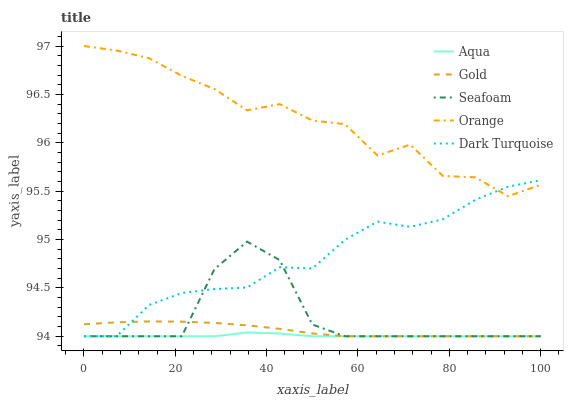Does Aqua have the minimum area under the curve?
Answer yes or no. Yes. Does Orange have the maximum area under the curve?
Answer yes or no. Yes. Does Dark Turquoise have the minimum area under the curve?
Answer yes or no. No. Does Dark Turquoise have the maximum area under the curve?
Answer yes or no. No. Is Gold the smoothest?
Answer yes or no. Yes. Is Orange the roughest?
Answer yes or no. Yes. Is Dark Turquoise the smoothest?
Answer yes or no. No. Is Dark Turquoise the roughest?
Answer yes or no. No. Does Dark Turquoise have the lowest value?
Answer yes or no. Yes. Does Orange have the highest value?
Answer yes or no. Yes. Does Dark Turquoise have the highest value?
Answer yes or no. No. Is Gold less than Orange?
Answer yes or no. Yes. Is Orange greater than Gold?
Answer yes or no. Yes. Does Gold intersect Seafoam?
Answer yes or no. Yes. Is Gold less than Seafoam?
Answer yes or no. No. Is Gold greater than Seafoam?
Answer yes or no. No. Does Gold intersect Orange?
Answer yes or no. No. 